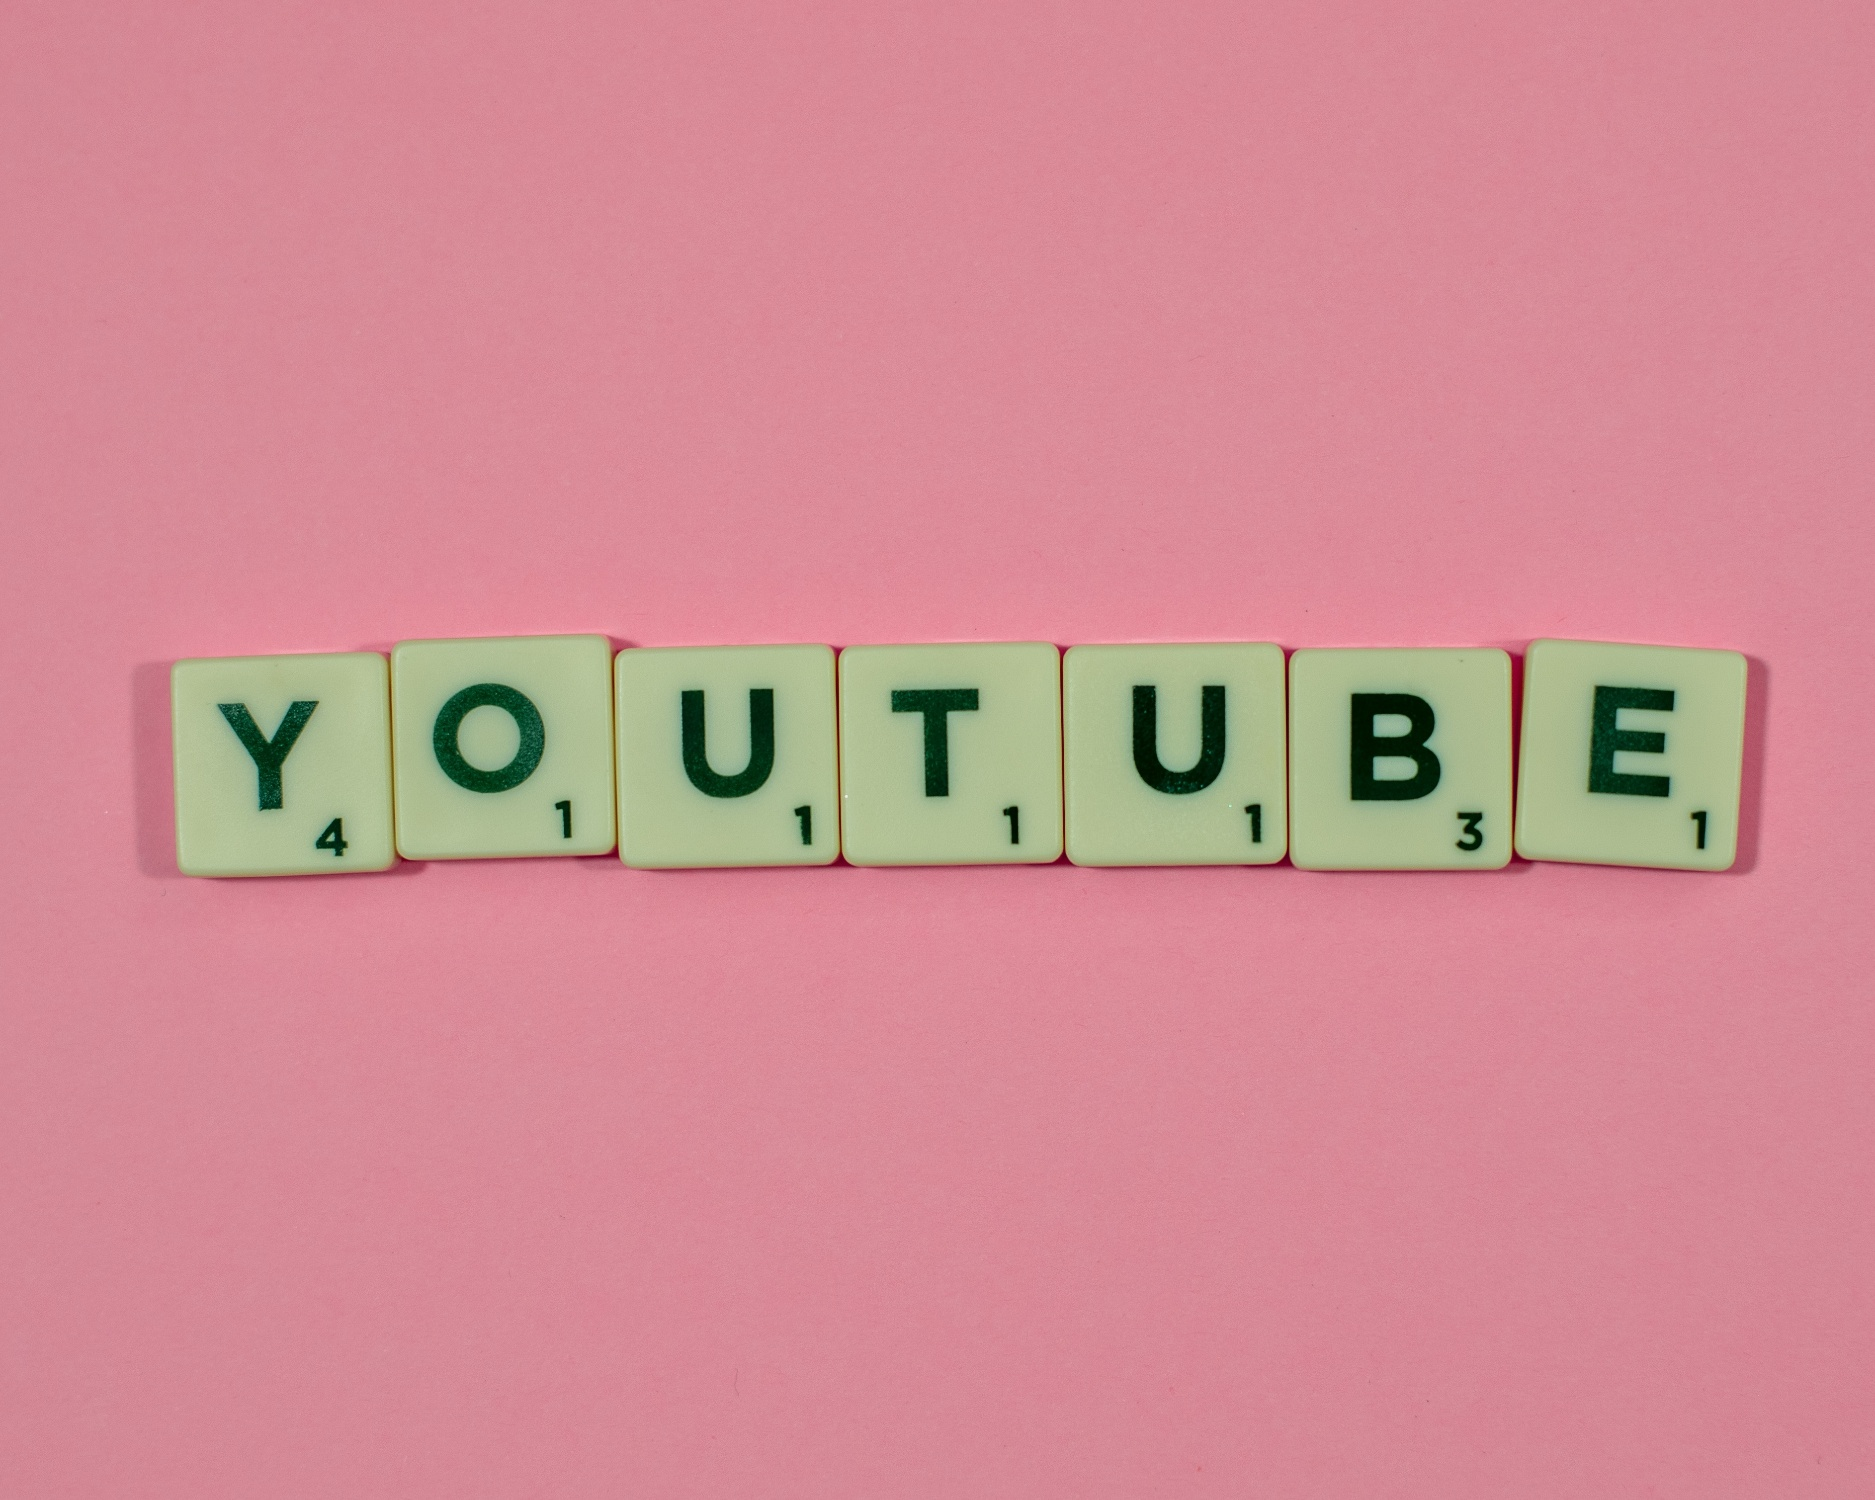Imagine if the Scrabble tiles in the image were to represent a story, what would that story be? Imagine a world where board games come to life. In this story, Scrabble tiles embark on a grand adventure. The tiles spelling 'YOUTUBE' might represent a team of characters, each with a unique personality reflecting their letter. 'Y,' the leader, is resourceful and always strategizing. 'O,' the empathetic one, always listens to others' ideas. 'U' twins bring balance, one adventurous and one cautious. 'T' is the creative genius, 'B' is the brave warrior, and 'E' is the energetic motivator. Together, they navigate a digital landscape, unlocking puzzles and creating content to inspire the world. Their journey is one of collaboration and creativity, reminding us of the possibilities when diverse talents unite. What do you think would be the next word they might spell out in their journey? In their journey, the Scrabble tiles might spell out 'CREATE' next. This word embodies the spirit of their adventure, emphasizing the power of imagination and innovation. By creating, they continue to unlock new paths, inspire others, and discover uncharted territories in both the digital and physical realms. 'CREATE' becomes not just a word, but their guiding principle as they explore new horizons together. 